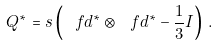Convert formula to latex. <formula><loc_0><loc_0><loc_500><loc_500>Q ^ { * } = s \left ( \ f d ^ { * } \otimes \ f d ^ { * } - \frac { 1 } { 3 } I \right ) \, .</formula> 